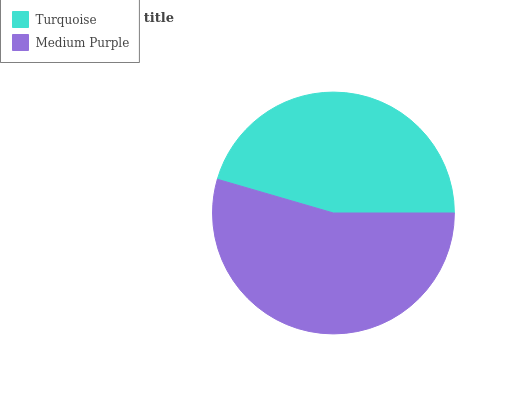Is Turquoise the minimum?
Answer yes or no. Yes. Is Medium Purple the maximum?
Answer yes or no. Yes. Is Medium Purple the minimum?
Answer yes or no. No. Is Medium Purple greater than Turquoise?
Answer yes or no. Yes. Is Turquoise less than Medium Purple?
Answer yes or no. Yes. Is Turquoise greater than Medium Purple?
Answer yes or no. No. Is Medium Purple less than Turquoise?
Answer yes or no. No. Is Medium Purple the high median?
Answer yes or no. Yes. Is Turquoise the low median?
Answer yes or no. Yes. Is Turquoise the high median?
Answer yes or no. No. Is Medium Purple the low median?
Answer yes or no. No. 